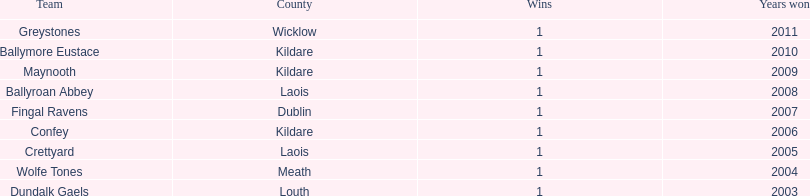What is the last team on the chart Dundalk Gaels. 